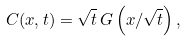Convert formula to latex. <formula><loc_0><loc_0><loc_500><loc_500>C ( x , t ) = \sqrt { t } \, G \left ( { x } / { \sqrt { t } } \right ) ,</formula> 